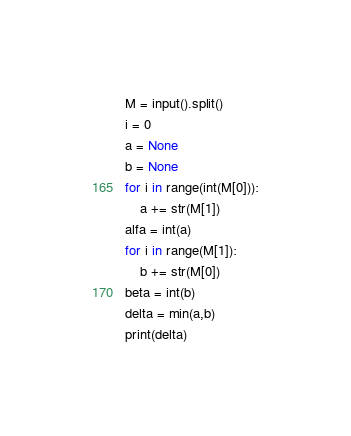Convert code to text. <code><loc_0><loc_0><loc_500><loc_500><_Python_>M = input().split()
i = 0
a = None
b = None
for i in range(int(M[0])):
    a += str(M[1])
alfa = int(a)
for i in range(M[1]):
    b += str(M[0])
beta = int(b)
delta = min(a,b)
print(delta)</code> 